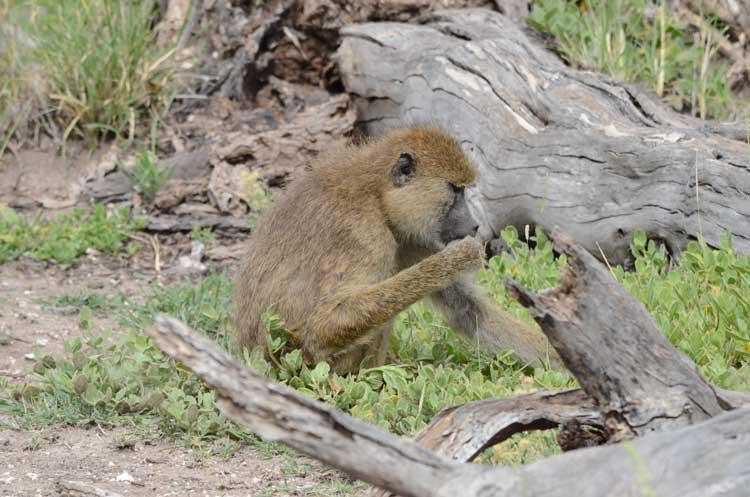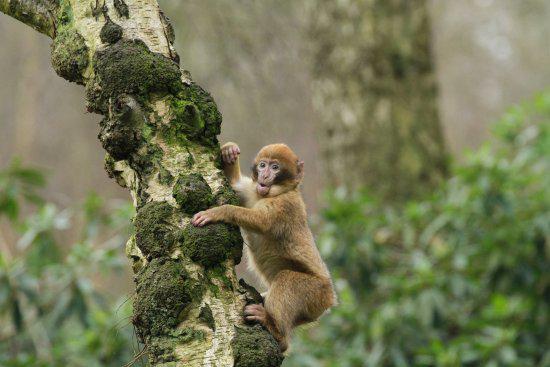The first image is the image on the left, the second image is the image on the right. Analyze the images presented: Is the assertion "at least two baboons are climbimg a tree in the image pair" valid? Answer yes or no. No. The first image is the image on the left, the second image is the image on the right. Considering the images on both sides, is "The monkeys are actively climbing trees." valid? Answer yes or no. No. 